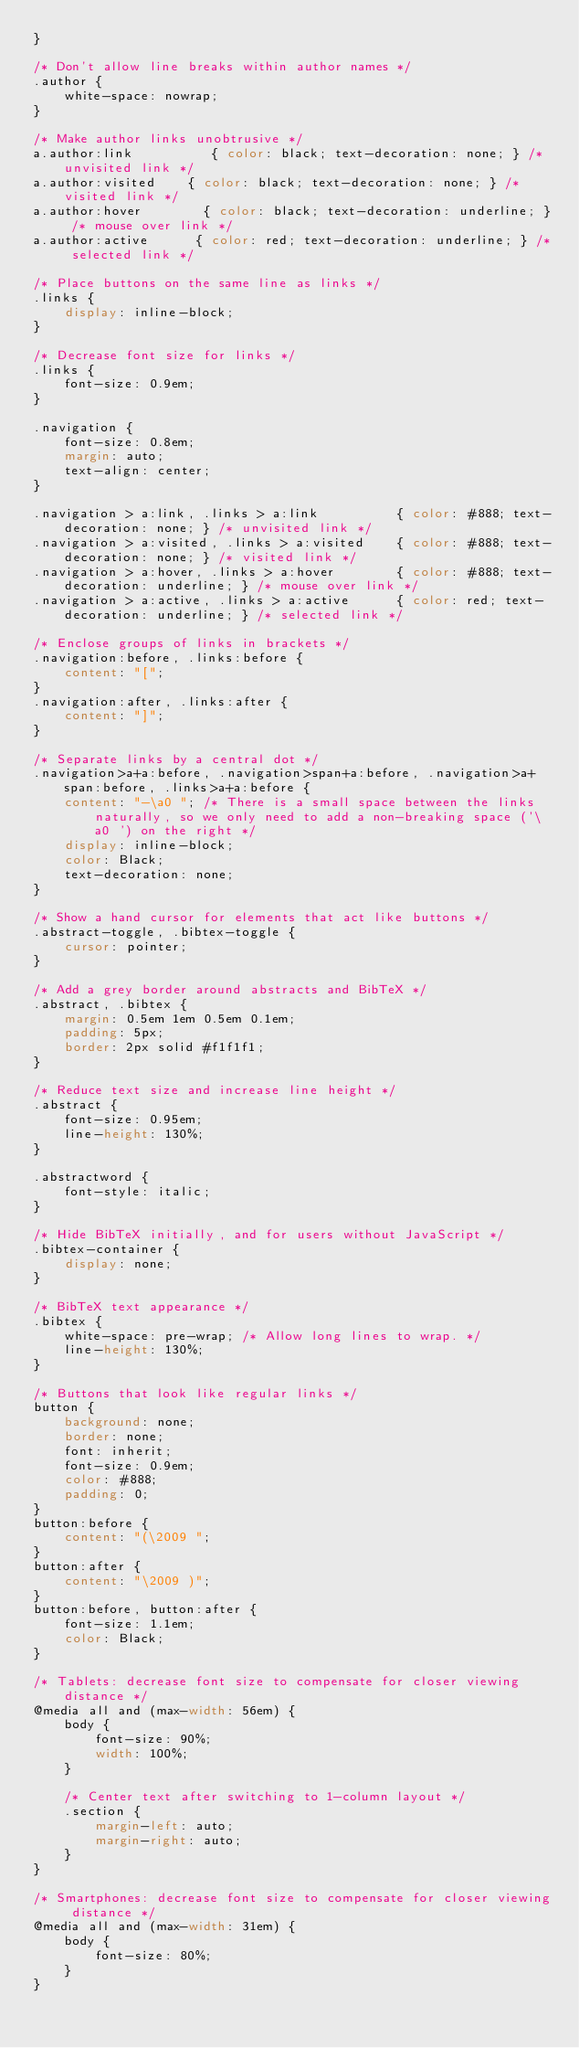<code> <loc_0><loc_0><loc_500><loc_500><_CSS_>}

/* Don't allow line breaks within author names */
.author {
    white-space: nowrap;
}

/* Make author links unobtrusive */
a.author:link          { color: black; text-decoration: none; } /* unvisited link */
a.author:visited    { color: black; text-decoration: none; } /* visited link */
a.author:hover        { color: black; text-decoration: underline; } /* mouse over link */
a.author:active      { color: red; text-decoration: underline; } /* selected link */

/* Place buttons on the same line as links */
.links {
    display: inline-block;
}

/* Decrease font size for links */
.links {
    font-size: 0.9em;
}

.navigation {
    font-size: 0.8em;
    margin: auto;
    text-align: center;
}

.navigation > a:link, .links > a:link          { color: #888; text-decoration: none; } /* unvisited link */
.navigation > a:visited, .links > a:visited    { color: #888; text-decoration: none; } /* visited link */
.navigation > a:hover, .links > a:hover        { color: #888; text-decoration: underline; } /* mouse over link */
.navigation > a:active, .links > a:active      { color: red; text-decoration: underline; } /* selected link */

/* Enclose groups of links in brackets */
.navigation:before, .links:before {
    content: "[";
}
.navigation:after, .links:after {
    content: "]";
}

/* Separate links by a central dot */
.navigation>a+a:before, .navigation>span+a:before, .navigation>a+span:before, .links>a+a:before {
    content: "-\a0 "; /* There is a small space between the links naturally, so we only need to add a non-breaking space ('\a0 ') on the right */
    display: inline-block;
    color: Black;
    text-decoration: none;
}

/* Show a hand cursor for elements that act like buttons */
.abstract-toggle, .bibtex-toggle {
    cursor: pointer;
}

/* Add a grey border around abstracts and BibTeX */
.abstract, .bibtex {
    margin: 0.5em 1em 0.5em 0.1em;
    padding: 5px;
    border: 2px solid #f1f1f1;
}

/* Reduce text size and increase line height */
.abstract {
    font-size: 0.95em;
    line-height: 130%;
}

.abstractword {
    font-style: italic;
}

/* Hide BibTeX initially, and for users without JavaScript */
.bibtex-container {
    display: none;
}

/* BibTeX text appearance */
.bibtex {
    white-space: pre-wrap; /* Allow long lines to wrap. */
    line-height: 130%;
}

/* Buttons that look like regular links */
button {
    background: none;
    border: none;
    font: inherit;
    font-size: 0.9em;
    color: #888;
    padding: 0;
}
button:before {
    content: "(\2009 ";
}
button:after {
    content: "\2009 )";
}
button:before, button:after {
    font-size: 1.1em;
    color: Black;
}

/* Tablets: decrease font size to compensate for closer viewing distance */
@media all and (max-width: 56em) {
    body {
        font-size: 90%;
        width: 100%;
    }
    
    /* Center text after switching to 1-column layout */
    .section {
        margin-left: auto;
        margin-right: auto;
    }
}

/* Smartphones: decrease font size to compensate for closer viewing distance */
@media all and (max-width: 31em) {
    body {
        font-size: 80%;
    }
}</code> 